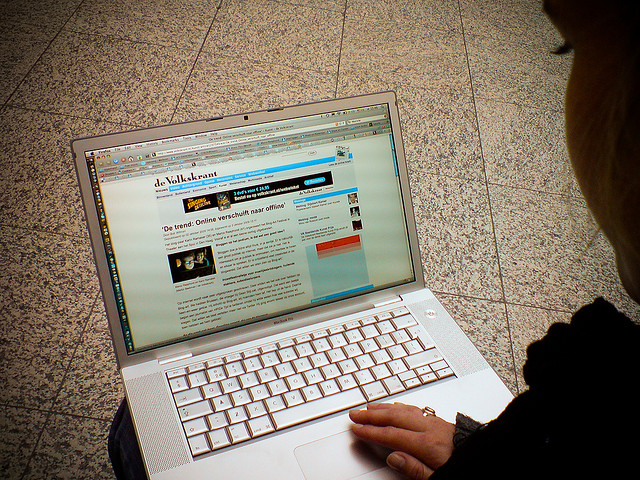Identify the text displayed in this image. online near 3 2 1 v C D X Z S W Q A Volkskrant de 